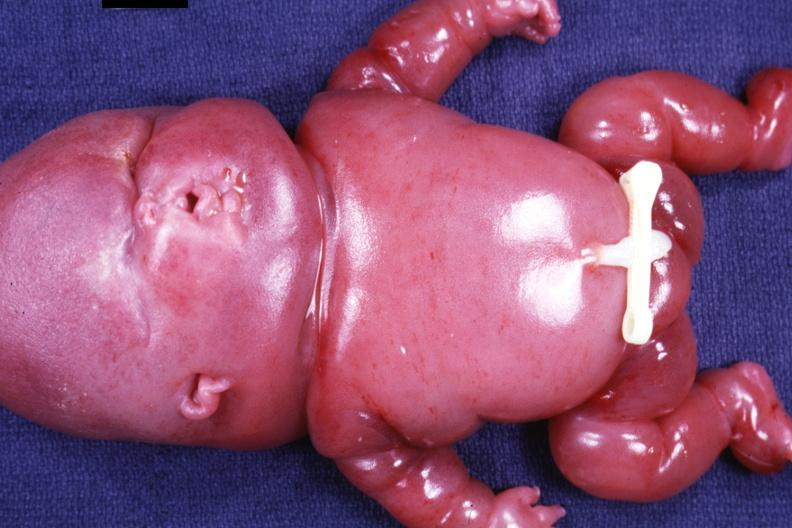s lymphangiomatosis present?
Answer the question using a single word or phrase. Yes 